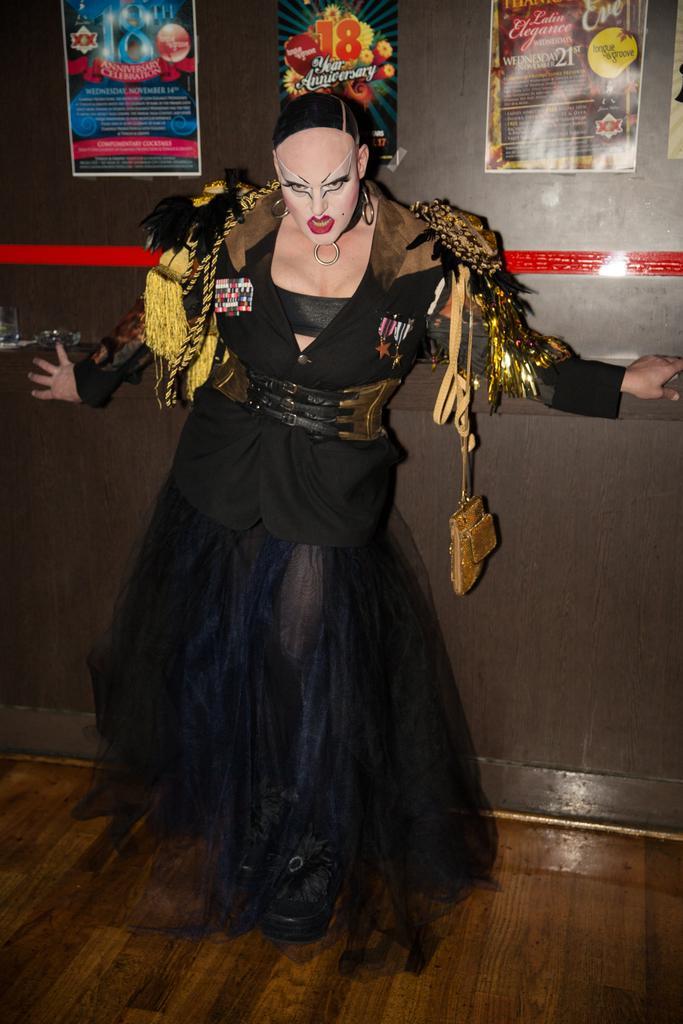Describe this image in one or two sentences. In this picture we can see a woman wearing black costume, standing in front and giving scary pose to the camera. Behind we can see the black wall with paper posters. 